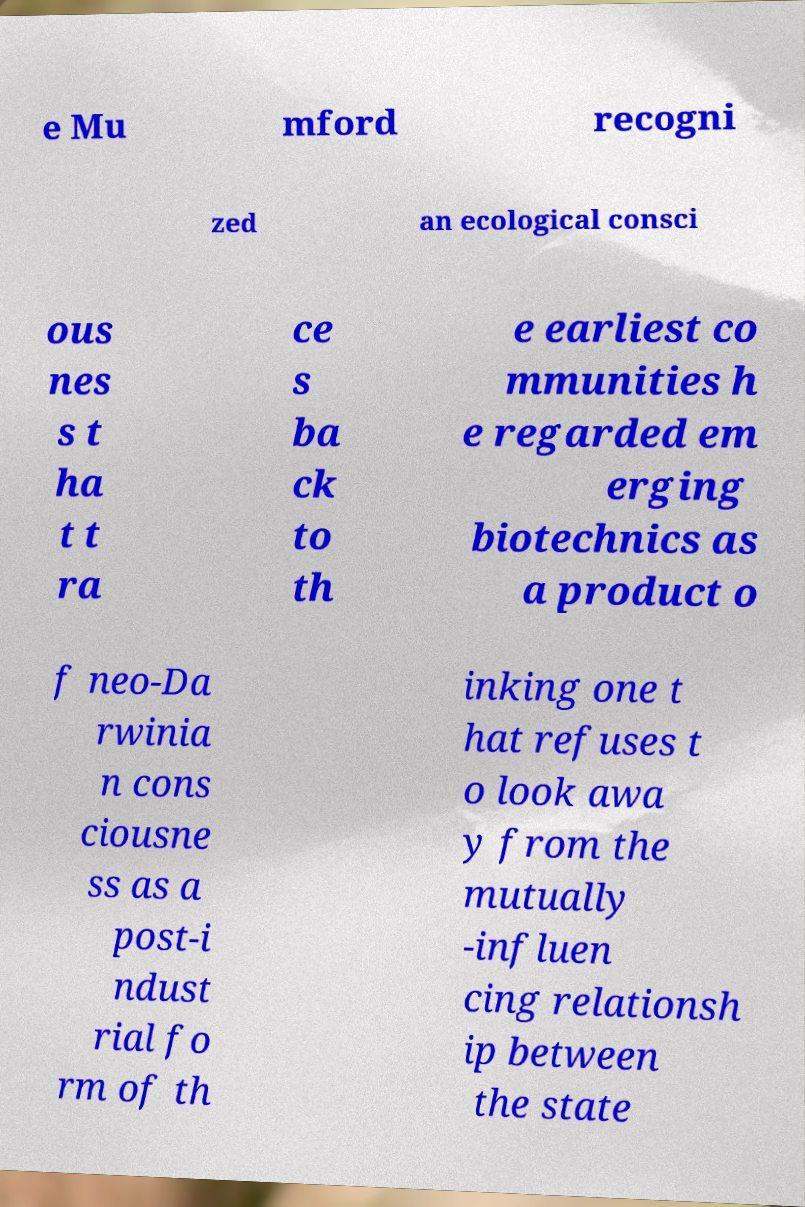Could you assist in decoding the text presented in this image and type it out clearly? e Mu mford recogni zed an ecological consci ous nes s t ha t t ra ce s ba ck to th e earliest co mmunities h e regarded em erging biotechnics as a product o f neo-Da rwinia n cons ciousne ss as a post-i ndust rial fo rm of th inking one t hat refuses t o look awa y from the mutually -influen cing relationsh ip between the state 